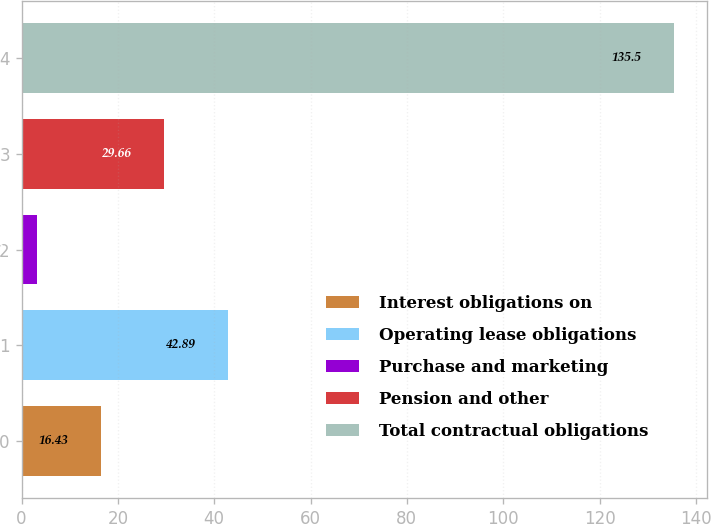Convert chart to OTSL. <chart><loc_0><loc_0><loc_500><loc_500><bar_chart><fcel>Interest obligations on<fcel>Operating lease obligations<fcel>Purchase and marketing<fcel>Pension and other<fcel>Total contractual obligations<nl><fcel>16.43<fcel>42.89<fcel>3.2<fcel>29.66<fcel>135.5<nl></chart> 